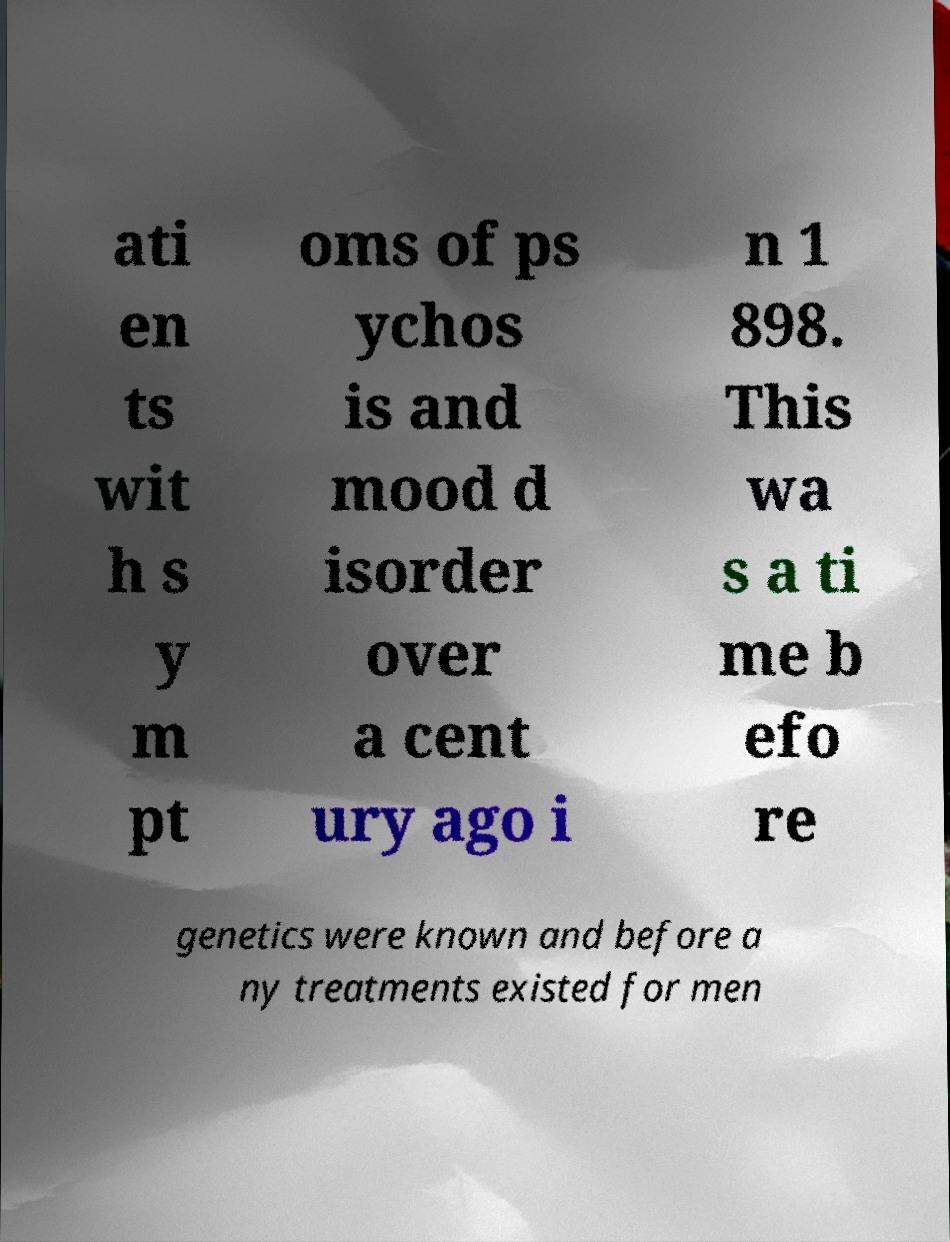Can you read and provide the text displayed in the image?This photo seems to have some interesting text. Can you extract and type it out for me? ati en ts wit h s y m pt oms of ps ychos is and mood d isorder over a cent ury ago i n 1 898. This wa s a ti me b efo re genetics were known and before a ny treatments existed for men 